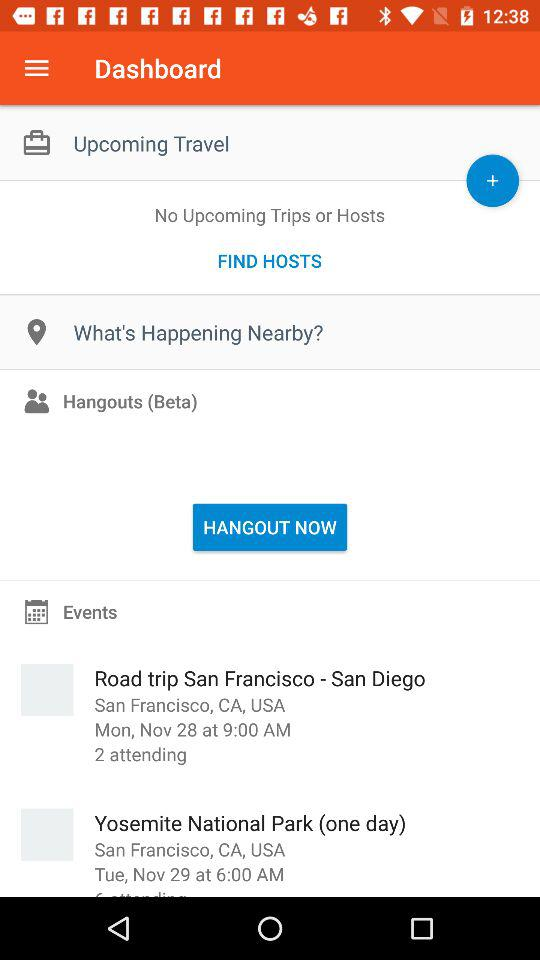What is the venue of the "Road trip San Francisco - San Diego" event? The venue of the "Road trip San Francisco - San Diego" event is San Francisco, CA, USA. 